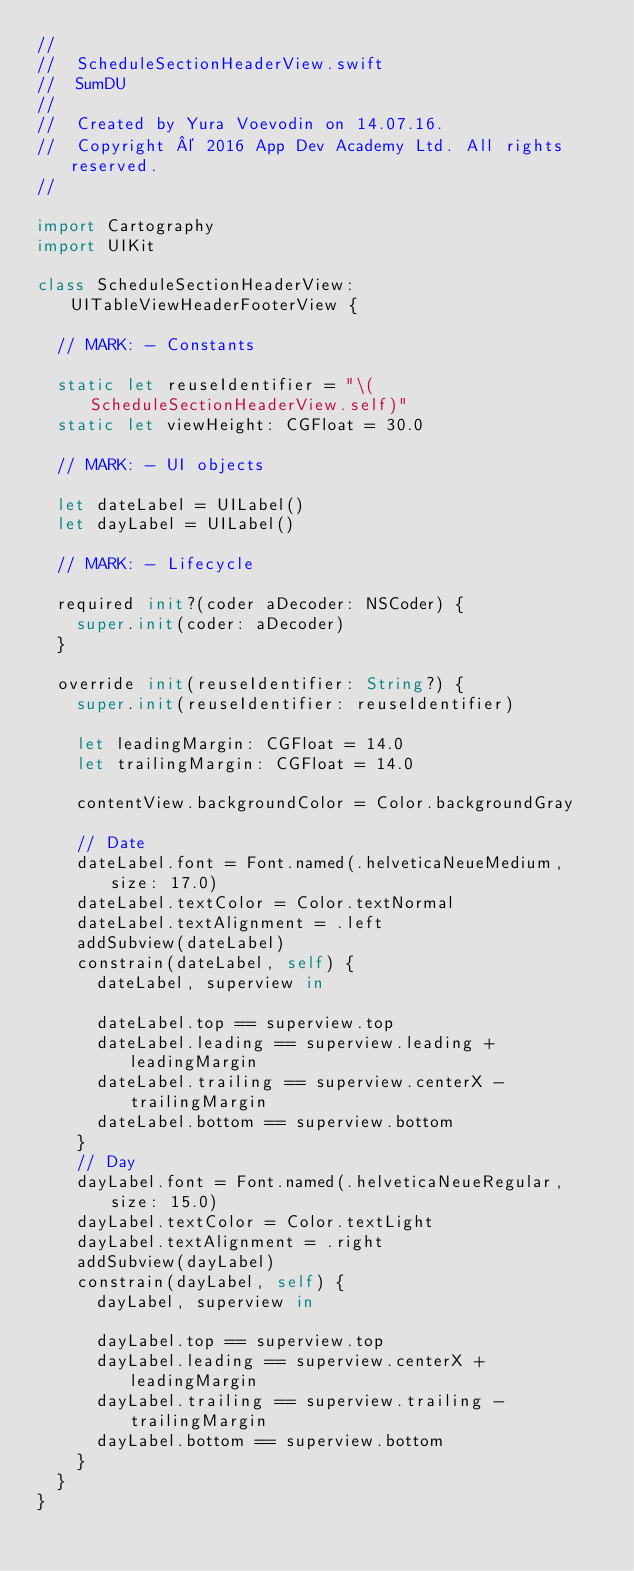Convert code to text. <code><loc_0><loc_0><loc_500><loc_500><_Swift_>//
//  ScheduleSectionHeaderView.swift
//  SumDU
//
//  Created by Yura Voevodin on 14.07.16.
//  Copyright © 2016 App Dev Academy Ltd. All rights reserved.
//

import Cartography
import UIKit

class ScheduleSectionHeaderView: UITableViewHeaderFooterView {
  
  // MARK: - Constants
  
  static let reuseIdentifier = "\(ScheduleSectionHeaderView.self)"
  static let viewHeight: CGFloat = 30.0
  
  // MARK: - UI objects
  
  let dateLabel = UILabel()
  let dayLabel = UILabel()
  
  // MARK: - Lifecycle
  
  required init?(coder aDecoder: NSCoder) {
    super.init(coder: aDecoder)
  }
  
  override init(reuseIdentifier: String?) {
    super.init(reuseIdentifier: reuseIdentifier)
    
    let leadingMargin: CGFloat = 14.0
    let trailingMargin: CGFloat = 14.0
    
    contentView.backgroundColor = Color.backgroundGray
    
    // Date
    dateLabel.font = Font.named(.helveticaNeueMedium, size: 17.0)
    dateLabel.textColor = Color.textNormal
    dateLabel.textAlignment = .left
    addSubview(dateLabel)
    constrain(dateLabel, self) {
      dateLabel, superview in
      
      dateLabel.top == superview.top
      dateLabel.leading == superview.leading + leadingMargin
      dateLabel.trailing == superview.centerX - trailingMargin
      dateLabel.bottom == superview.bottom
    }
    // Day
    dayLabel.font = Font.named(.helveticaNeueRegular, size: 15.0)
    dayLabel.textColor = Color.textLight
    dayLabel.textAlignment = .right
    addSubview(dayLabel)
    constrain(dayLabel, self) {
      dayLabel, superview in
      
      dayLabel.top == superview.top
      dayLabel.leading == superview.centerX + leadingMargin
      dayLabel.trailing == superview.trailing - trailingMargin
      dayLabel.bottom == superview.bottom
    }
  }
}
</code> 